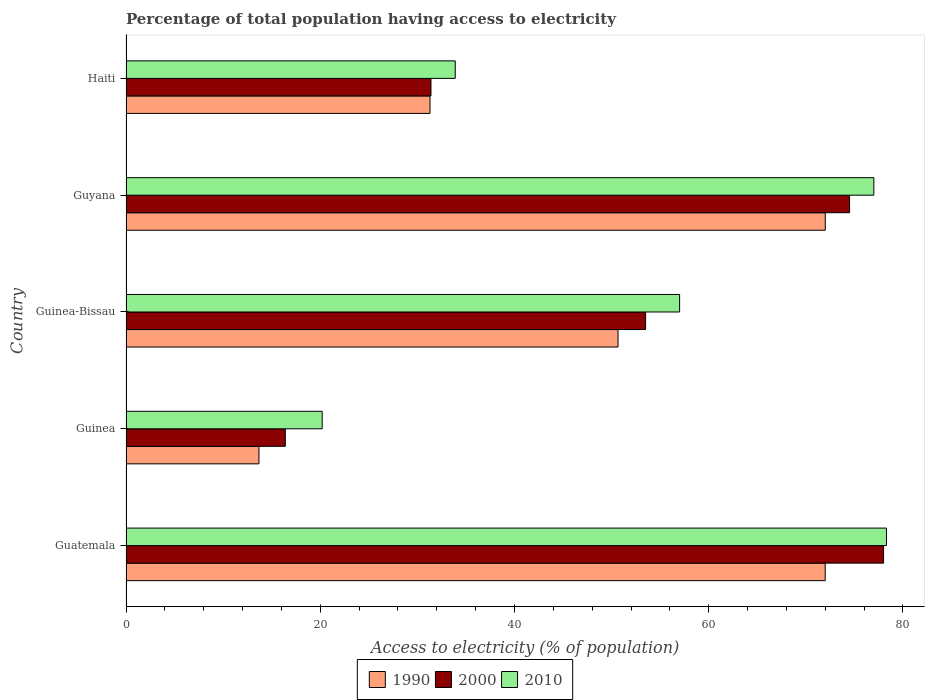How many groups of bars are there?
Your response must be concise. 5. Are the number of bars on each tick of the Y-axis equal?
Provide a succinct answer. Yes. How many bars are there on the 1st tick from the bottom?
Give a very brief answer. 3. What is the label of the 4th group of bars from the top?
Ensure brevity in your answer.  Guinea. In how many cases, is the number of bars for a given country not equal to the number of legend labels?
Your answer should be compact. 0. What is the percentage of population that have access to electricity in 1990 in Guinea-Bissau?
Offer a very short reply. 50.66. Across all countries, what is the maximum percentage of population that have access to electricity in 1990?
Keep it short and to the point. 72. Across all countries, what is the minimum percentage of population that have access to electricity in 2010?
Make the answer very short. 20.2. In which country was the percentage of population that have access to electricity in 2000 maximum?
Your answer should be very brief. Guatemala. In which country was the percentage of population that have access to electricity in 1990 minimum?
Give a very brief answer. Guinea. What is the total percentage of population that have access to electricity in 2010 in the graph?
Offer a terse response. 266.4. What is the difference between the percentage of population that have access to electricity in 1990 in Guatemala and that in Guyana?
Give a very brief answer. -0.01. What is the difference between the percentage of population that have access to electricity in 1990 in Guatemala and the percentage of population that have access to electricity in 2000 in Haiti?
Offer a terse response. 40.59. What is the average percentage of population that have access to electricity in 2000 per country?
Offer a very short reply. 50.76. What is the difference between the percentage of population that have access to electricity in 1990 and percentage of population that have access to electricity in 2010 in Guinea-Bissau?
Make the answer very short. -6.34. In how many countries, is the percentage of population that have access to electricity in 1990 greater than 12 %?
Keep it short and to the point. 5. What is the ratio of the percentage of population that have access to electricity in 2000 in Guatemala to that in Haiti?
Keep it short and to the point. 2.48. Is the percentage of population that have access to electricity in 2000 in Guatemala less than that in Guinea-Bissau?
Provide a succinct answer. No. Is the difference between the percentage of population that have access to electricity in 1990 in Guinea-Bissau and Haiti greater than the difference between the percentage of population that have access to electricity in 2010 in Guinea-Bissau and Haiti?
Your answer should be compact. No. What is the difference between the highest and the second highest percentage of population that have access to electricity in 2010?
Offer a terse response. 1.3. What is the difference between the highest and the lowest percentage of population that have access to electricity in 2000?
Provide a short and direct response. 61.6. What does the 3rd bar from the bottom in Guinea represents?
Your answer should be compact. 2010. Are all the bars in the graph horizontal?
Offer a terse response. Yes. How many countries are there in the graph?
Give a very brief answer. 5. Are the values on the major ticks of X-axis written in scientific E-notation?
Your response must be concise. No. Does the graph contain any zero values?
Provide a short and direct response. No. How many legend labels are there?
Ensure brevity in your answer.  3. What is the title of the graph?
Your answer should be very brief. Percentage of total population having access to electricity. What is the label or title of the X-axis?
Make the answer very short. Access to electricity (% of population). What is the Access to electricity (% of population) in 1990 in Guatemala?
Give a very brief answer. 71.99. What is the Access to electricity (% of population) in 2010 in Guatemala?
Offer a terse response. 78.3. What is the Access to electricity (% of population) of 1990 in Guinea?
Keep it short and to the point. 13.69. What is the Access to electricity (% of population) in 2010 in Guinea?
Offer a terse response. 20.2. What is the Access to electricity (% of population) in 1990 in Guinea-Bissau?
Offer a very short reply. 50.66. What is the Access to electricity (% of population) in 2000 in Guinea-Bissau?
Your answer should be very brief. 53.5. What is the Access to electricity (% of population) in 2010 in Guinea-Bissau?
Provide a succinct answer. 57. What is the Access to electricity (% of population) of 2000 in Guyana?
Offer a terse response. 74.5. What is the Access to electricity (% of population) in 2010 in Guyana?
Give a very brief answer. 77. What is the Access to electricity (% of population) in 1990 in Haiti?
Your response must be concise. 31.3. What is the Access to electricity (% of population) in 2000 in Haiti?
Provide a short and direct response. 31.4. What is the Access to electricity (% of population) of 2010 in Haiti?
Offer a very short reply. 33.9. Across all countries, what is the maximum Access to electricity (% of population) in 1990?
Provide a succinct answer. 72. Across all countries, what is the maximum Access to electricity (% of population) of 2000?
Provide a succinct answer. 78. Across all countries, what is the maximum Access to electricity (% of population) in 2010?
Keep it short and to the point. 78.3. Across all countries, what is the minimum Access to electricity (% of population) in 1990?
Offer a terse response. 13.69. Across all countries, what is the minimum Access to electricity (% of population) in 2000?
Make the answer very short. 16.4. Across all countries, what is the minimum Access to electricity (% of population) of 2010?
Offer a very short reply. 20.2. What is the total Access to electricity (% of population) of 1990 in the graph?
Your answer should be compact. 239.64. What is the total Access to electricity (% of population) of 2000 in the graph?
Provide a succinct answer. 253.8. What is the total Access to electricity (% of population) in 2010 in the graph?
Make the answer very short. 266.4. What is the difference between the Access to electricity (% of population) of 1990 in Guatemala and that in Guinea?
Make the answer very short. 58.3. What is the difference between the Access to electricity (% of population) in 2000 in Guatemala and that in Guinea?
Provide a succinct answer. 61.6. What is the difference between the Access to electricity (% of population) of 2010 in Guatemala and that in Guinea?
Your answer should be compact. 58.1. What is the difference between the Access to electricity (% of population) of 1990 in Guatemala and that in Guinea-Bissau?
Make the answer very short. 21.33. What is the difference between the Access to electricity (% of population) of 2000 in Guatemala and that in Guinea-Bissau?
Your answer should be very brief. 24.5. What is the difference between the Access to electricity (% of population) in 2010 in Guatemala and that in Guinea-Bissau?
Your response must be concise. 21.3. What is the difference between the Access to electricity (% of population) of 1990 in Guatemala and that in Guyana?
Offer a very short reply. -0.01. What is the difference between the Access to electricity (% of population) in 2010 in Guatemala and that in Guyana?
Provide a short and direct response. 1.3. What is the difference between the Access to electricity (% of population) of 1990 in Guatemala and that in Haiti?
Provide a short and direct response. 40.69. What is the difference between the Access to electricity (% of population) of 2000 in Guatemala and that in Haiti?
Your response must be concise. 46.6. What is the difference between the Access to electricity (% of population) of 2010 in Guatemala and that in Haiti?
Your answer should be very brief. 44.4. What is the difference between the Access to electricity (% of population) of 1990 in Guinea and that in Guinea-Bissau?
Ensure brevity in your answer.  -36.97. What is the difference between the Access to electricity (% of population) in 2000 in Guinea and that in Guinea-Bissau?
Ensure brevity in your answer.  -37.1. What is the difference between the Access to electricity (% of population) in 2010 in Guinea and that in Guinea-Bissau?
Your answer should be very brief. -36.8. What is the difference between the Access to electricity (% of population) in 1990 in Guinea and that in Guyana?
Give a very brief answer. -58.31. What is the difference between the Access to electricity (% of population) in 2000 in Guinea and that in Guyana?
Provide a short and direct response. -58.1. What is the difference between the Access to electricity (% of population) in 2010 in Guinea and that in Guyana?
Provide a succinct answer. -56.8. What is the difference between the Access to electricity (% of population) of 1990 in Guinea and that in Haiti?
Offer a terse response. -17.61. What is the difference between the Access to electricity (% of population) of 2010 in Guinea and that in Haiti?
Ensure brevity in your answer.  -13.7. What is the difference between the Access to electricity (% of population) of 1990 in Guinea-Bissau and that in Guyana?
Keep it short and to the point. -21.34. What is the difference between the Access to electricity (% of population) in 2010 in Guinea-Bissau and that in Guyana?
Ensure brevity in your answer.  -20. What is the difference between the Access to electricity (% of population) in 1990 in Guinea-Bissau and that in Haiti?
Give a very brief answer. 19.36. What is the difference between the Access to electricity (% of population) of 2000 in Guinea-Bissau and that in Haiti?
Offer a very short reply. 22.1. What is the difference between the Access to electricity (% of population) of 2010 in Guinea-Bissau and that in Haiti?
Your answer should be very brief. 23.1. What is the difference between the Access to electricity (% of population) in 1990 in Guyana and that in Haiti?
Your answer should be very brief. 40.7. What is the difference between the Access to electricity (% of population) of 2000 in Guyana and that in Haiti?
Offer a terse response. 43.1. What is the difference between the Access to electricity (% of population) of 2010 in Guyana and that in Haiti?
Offer a terse response. 43.1. What is the difference between the Access to electricity (% of population) of 1990 in Guatemala and the Access to electricity (% of population) of 2000 in Guinea?
Offer a very short reply. 55.59. What is the difference between the Access to electricity (% of population) in 1990 in Guatemala and the Access to electricity (% of population) in 2010 in Guinea?
Offer a very short reply. 51.79. What is the difference between the Access to electricity (% of population) of 2000 in Guatemala and the Access to electricity (% of population) of 2010 in Guinea?
Provide a short and direct response. 57.8. What is the difference between the Access to electricity (% of population) of 1990 in Guatemala and the Access to electricity (% of population) of 2000 in Guinea-Bissau?
Offer a very short reply. 18.49. What is the difference between the Access to electricity (% of population) in 1990 in Guatemala and the Access to electricity (% of population) in 2010 in Guinea-Bissau?
Offer a very short reply. 14.99. What is the difference between the Access to electricity (% of population) in 2000 in Guatemala and the Access to electricity (% of population) in 2010 in Guinea-Bissau?
Provide a succinct answer. 21. What is the difference between the Access to electricity (% of population) of 1990 in Guatemala and the Access to electricity (% of population) of 2000 in Guyana?
Provide a succinct answer. -2.51. What is the difference between the Access to electricity (% of population) in 1990 in Guatemala and the Access to electricity (% of population) in 2010 in Guyana?
Your response must be concise. -5.01. What is the difference between the Access to electricity (% of population) of 1990 in Guatemala and the Access to electricity (% of population) of 2000 in Haiti?
Offer a very short reply. 40.59. What is the difference between the Access to electricity (% of population) in 1990 in Guatemala and the Access to electricity (% of population) in 2010 in Haiti?
Your answer should be compact. 38.09. What is the difference between the Access to electricity (% of population) in 2000 in Guatemala and the Access to electricity (% of population) in 2010 in Haiti?
Offer a terse response. 44.1. What is the difference between the Access to electricity (% of population) in 1990 in Guinea and the Access to electricity (% of population) in 2000 in Guinea-Bissau?
Ensure brevity in your answer.  -39.81. What is the difference between the Access to electricity (% of population) in 1990 in Guinea and the Access to electricity (% of population) in 2010 in Guinea-Bissau?
Offer a terse response. -43.31. What is the difference between the Access to electricity (% of population) in 2000 in Guinea and the Access to electricity (% of population) in 2010 in Guinea-Bissau?
Your response must be concise. -40.6. What is the difference between the Access to electricity (% of population) of 1990 in Guinea and the Access to electricity (% of population) of 2000 in Guyana?
Provide a short and direct response. -60.81. What is the difference between the Access to electricity (% of population) of 1990 in Guinea and the Access to electricity (% of population) of 2010 in Guyana?
Keep it short and to the point. -63.31. What is the difference between the Access to electricity (% of population) in 2000 in Guinea and the Access to electricity (% of population) in 2010 in Guyana?
Offer a very short reply. -60.6. What is the difference between the Access to electricity (% of population) in 1990 in Guinea and the Access to electricity (% of population) in 2000 in Haiti?
Give a very brief answer. -17.71. What is the difference between the Access to electricity (% of population) of 1990 in Guinea and the Access to electricity (% of population) of 2010 in Haiti?
Provide a short and direct response. -20.21. What is the difference between the Access to electricity (% of population) in 2000 in Guinea and the Access to electricity (% of population) in 2010 in Haiti?
Provide a succinct answer. -17.5. What is the difference between the Access to electricity (% of population) of 1990 in Guinea-Bissau and the Access to electricity (% of population) of 2000 in Guyana?
Provide a succinct answer. -23.84. What is the difference between the Access to electricity (% of population) in 1990 in Guinea-Bissau and the Access to electricity (% of population) in 2010 in Guyana?
Offer a terse response. -26.34. What is the difference between the Access to electricity (% of population) in 2000 in Guinea-Bissau and the Access to electricity (% of population) in 2010 in Guyana?
Offer a very short reply. -23.5. What is the difference between the Access to electricity (% of population) of 1990 in Guinea-Bissau and the Access to electricity (% of population) of 2000 in Haiti?
Offer a very short reply. 19.26. What is the difference between the Access to electricity (% of population) of 1990 in Guinea-Bissau and the Access to electricity (% of population) of 2010 in Haiti?
Keep it short and to the point. 16.76. What is the difference between the Access to electricity (% of population) in 2000 in Guinea-Bissau and the Access to electricity (% of population) in 2010 in Haiti?
Your response must be concise. 19.6. What is the difference between the Access to electricity (% of population) of 1990 in Guyana and the Access to electricity (% of population) of 2000 in Haiti?
Ensure brevity in your answer.  40.6. What is the difference between the Access to electricity (% of population) in 1990 in Guyana and the Access to electricity (% of population) in 2010 in Haiti?
Make the answer very short. 38.1. What is the difference between the Access to electricity (% of population) of 2000 in Guyana and the Access to electricity (% of population) of 2010 in Haiti?
Provide a short and direct response. 40.6. What is the average Access to electricity (% of population) of 1990 per country?
Offer a very short reply. 47.93. What is the average Access to electricity (% of population) of 2000 per country?
Ensure brevity in your answer.  50.76. What is the average Access to electricity (% of population) of 2010 per country?
Your answer should be very brief. 53.28. What is the difference between the Access to electricity (% of population) in 1990 and Access to electricity (% of population) in 2000 in Guatemala?
Your answer should be compact. -6.01. What is the difference between the Access to electricity (% of population) in 1990 and Access to electricity (% of population) in 2010 in Guatemala?
Provide a short and direct response. -6.31. What is the difference between the Access to electricity (% of population) in 1990 and Access to electricity (% of population) in 2000 in Guinea?
Provide a short and direct response. -2.71. What is the difference between the Access to electricity (% of population) in 1990 and Access to electricity (% of population) in 2010 in Guinea?
Keep it short and to the point. -6.51. What is the difference between the Access to electricity (% of population) in 1990 and Access to electricity (% of population) in 2000 in Guinea-Bissau?
Keep it short and to the point. -2.84. What is the difference between the Access to electricity (% of population) in 1990 and Access to electricity (% of population) in 2010 in Guinea-Bissau?
Provide a succinct answer. -6.34. What is the difference between the Access to electricity (% of population) in 1990 and Access to electricity (% of population) in 2000 in Guyana?
Your answer should be very brief. -2.5. What is the difference between the Access to electricity (% of population) in 1990 and Access to electricity (% of population) in 2010 in Haiti?
Your answer should be compact. -2.6. What is the ratio of the Access to electricity (% of population) in 1990 in Guatemala to that in Guinea?
Provide a short and direct response. 5.26. What is the ratio of the Access to electricity (% of population) in 2000 in Guatemala to that in Guinea?
Your answer should be very brief. 4.76. What is the ratio of the Access to electricity (% of population) of 2010 in Guatemala to that in Guinea?
Provide a short and direct response. 3.88. What is the ratio of the Access to electricity (% of population) in 1990 in Guatemala to that in Guinea-Bissau?
Keep it short and to the point. 1.42. What is the ratio of the Access to electricity (% of population) of 2000 in Guatemala to that in Guinea-Bissau?
Provide a succinct answer. 1.46. What is the ratio of the Access to electricity (% of population) in 2010 in Guatemala to that in Guinea-Bissau?
Give a very brief answer. 1.37. What is the ratio of the Access to electricity (% of population) in 2000 in Guatemala to that in Guyana?
Your answer should be compact. 1.05. What is the ratio of the Access to electricity (% of population) of 2010 in Guatemala to that in Guyana?
Make the answer very short. 1.02. What is the ratio of the Access to electricity (% of population) of 1990 in Guatemala to that in Haiti?
Make the answer very short. 2.3. What is the ratio of the Access to electricity (% of population) in 2000 in Guatemala to that in Haiti?
Your answer should be very brief. 2.48. What is the ratio of the Access to electricity (% of population) of 2010 in Guatemala to that in Haiti?
Give a very brief answer. 2.31. What is the ratio of the Access to electricity (% of population) of 1990 in Guinea to that in Guinea-Bissau?
Keep it short and to the point. 0.27. What is the ratio of the Access to electricity (% of population) in 2000 in Guinea to that in Guinea-Bissau?
Keep it short and to the point. 0.31. What is the ratio of the Access to electricity (% of population) of 2010 in Guinea to that in Guinea-Bissau?
Provide a succinct answer. 0.35. What is the ratio of the Access to electricity (% of population) of 1990 in Guinea to that in Guyana?
Your answer should be very brief. 0.19. What is the ratio of the Access to electricity (% of population) in 2000 in Guinea to that in Guyana?
Keep it short and to the point. 0.22. What is the ratio of the Access to electricity (% of population) of 2010 in Guinea to that in Guyana?
Provide a succinct answer. 0.26. What is the ratio of the Access to electricity (% of population) of 1990 in Guinea to that in Haiti?
Offer a terse response. 0.44. What is the ratio of the Access to electricity (% of population) in 2000 in Guinea to that in Haiti?
Offer a very short reply. 0.52. What is the ratio of the Access to electricity (% of population) in 2010 in Guinea to that in Haiti?
Give a very brief answer. 0.6. What is the ratio of the Access to electricity (% of population) of 1990 in Guinea-Bissau to that in Guyana?
Ensure brevity in your answer.  0.7. What is the ratio of the Access to electricity (% of population) of 2000 in Guinea-Bissau to that in Guyana?
Keep it short and to the point. 0.72. What is the ratio of the Access to electricity (% of population) in 2010 in Guinea-Bissau to that in Guyana?
Keep it short and to the point. 0.74. What is the ratio of the Access to electricity (% of population) of 1990 in Guinea-Bissau to that in Haiti?
Offer a terse response. 1.62. What is the ratio of the Access to electricity (% of population) of 2000 in Guinea-Bissau to that in Haiti?
Provide a short and direct response. 1.7. What is the ratio of the Access to electricity (% of population) of 2010 in Guinea-Bissau to that in Haiti?
Keep it short and to the point. 1.68. What is the ratio of the Access to electricity (% of population) in 1990 in Guyana to that in Haiti?
Offer a very short reply. 2.3. What is the ratio of the Access to electricity (% of population) in 2000 in Guyana to that in Haiti?
Provide a succinct answer. 2.37. What is the ratio of the Access to electricity (% of population) in 2010 in Guyana to that in Haiti?
Provide a short and direct response. 2.27. What is the difference between the highest and the second highest Access to electricity (% of population) of 1990?
Provide a succinct answer. 0.01. What is the difference between the highest and the lowest Access to electricity (% of population) of 1990?
Provide a short and direct response. 58.31. What is the difference between the highest and the lowest Access to electricity (% of population) of 2000?
Give a very brief answer. 61.6. What is the difference between the highest and the lowest Access to electricity (% of population) in 2010?
Make the answer very short. 58.1. 